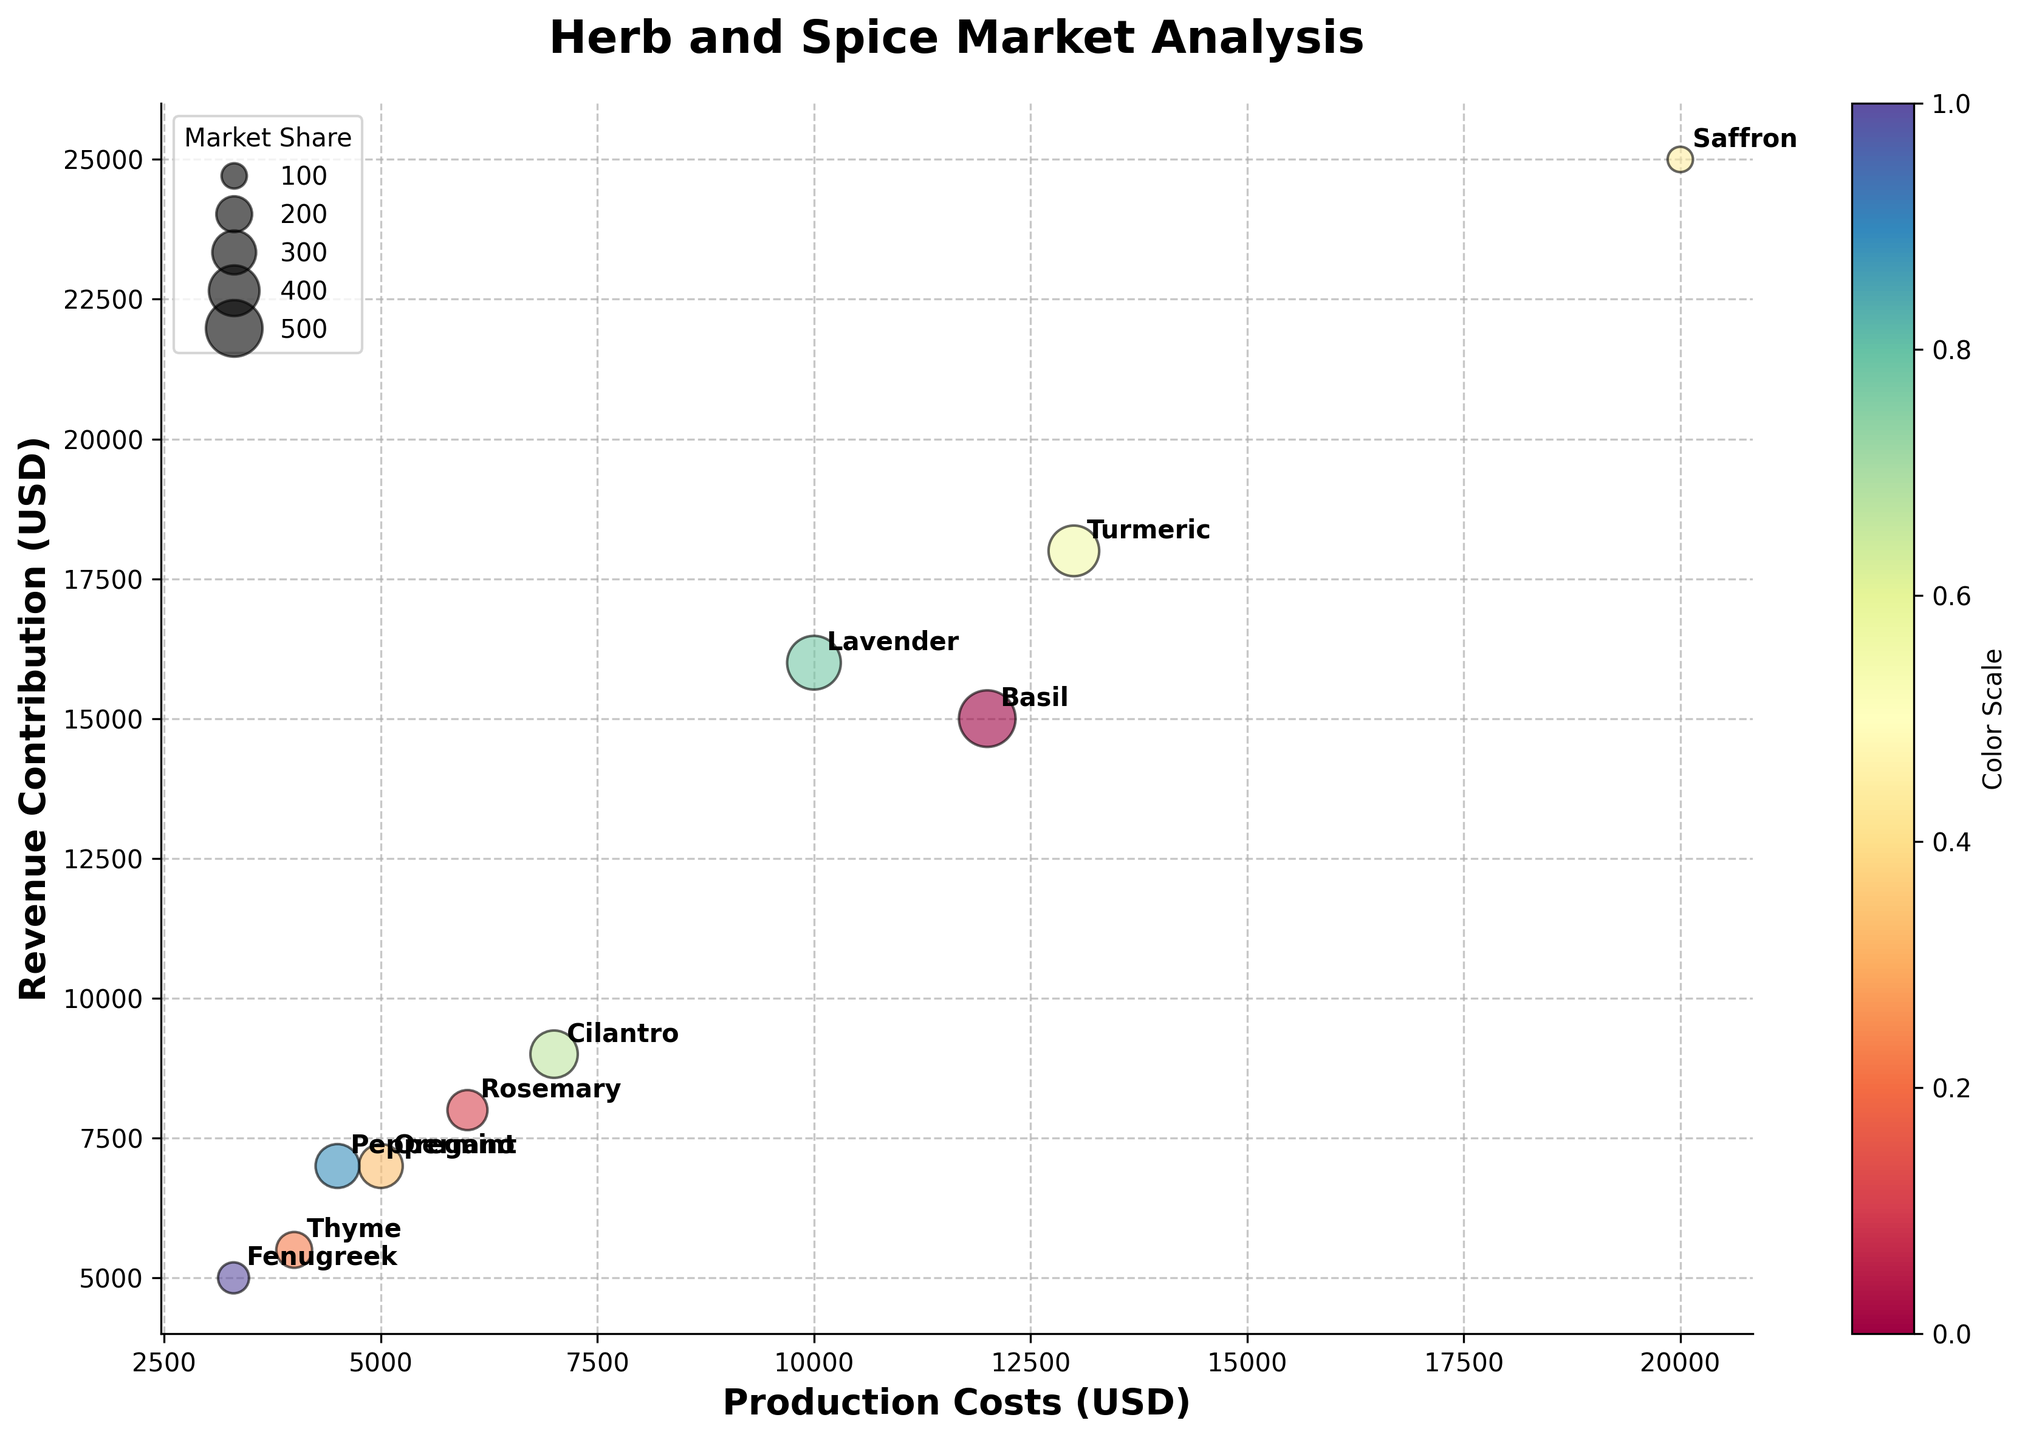What's the title of the chart? The title of the chart is prominently displayed at the top.
Answer: Herb and Spice Market Analysis Which herb or spice has the highest revenue contribution? By looking at the highest point on the Y-axis, we can see that Saffron has the highest revenue contribution as it is placed highest.
Answer: Saffron Which herb or spice has the lowest market share? The size of the bubbles represents market share, and the smallest bubble with a clear label is Fenugreek.
Answer: Fenugreek How many herbs and spices are represented in the chart? By counting the number of bubbles (each representing a different herb or spice), we can determine that there are 10 data points.
Answer: 10 What is the relationship between production costs and revenue contribution for Basil? For Basil, the relevant bubble is annotated with data. By comparing its X position (Production Costs) and Y position (Revenue Contribution), Basil is marked at $12,000 on the X-axis and $15,000 on the Y-axis.
Answer: Production costs: $12,000, Revenue contribution: $15,000 What is the average production cost of Oregano and Turmeric? By locating Oregano and Turmeric on the chart and noting their positions on the X-axis, Oregano is at $5,000 and Turmeric is at $13,000. The average of these two values is ($5,000 + $13,000) / 2.
Answer: $9,000 Which herb or spice has the same production costs but different revenue contribution compared to Rosemary? First, locate Rosemary on the chart at $6,000 production costs. Then, identify other bubbles at the same X position. Peppermint is at $6,000 with different Y position compared to Rosemary.
Answer: Peppermint Which has a higher production cost, Lavender or Cilantro? By comparing the X positions of the Lavender and Cilantro bubbles, it is clear:
Lavender's X position: $10,000
Cilantro's X position: $7,000.
Answer: Lavender How much more revenue does Turmeric generate compared to Thyme? Find the Y positions for Turmeric and Thyme:
Turmeric: $18,000
Thyme: $5,500
Now, calculate the difference: $18,000 - $5,500.
Answer: $12,500 Which herb or spice has a market share between Peppermint and Lavender? First, determine market shares for Peppermint (6%) and Lavender (9%) by their bubble sizes, and find the bubble whose size falls within this range. Cilantro with a 7% market share fits this criterion.
Answer: Cilantro 